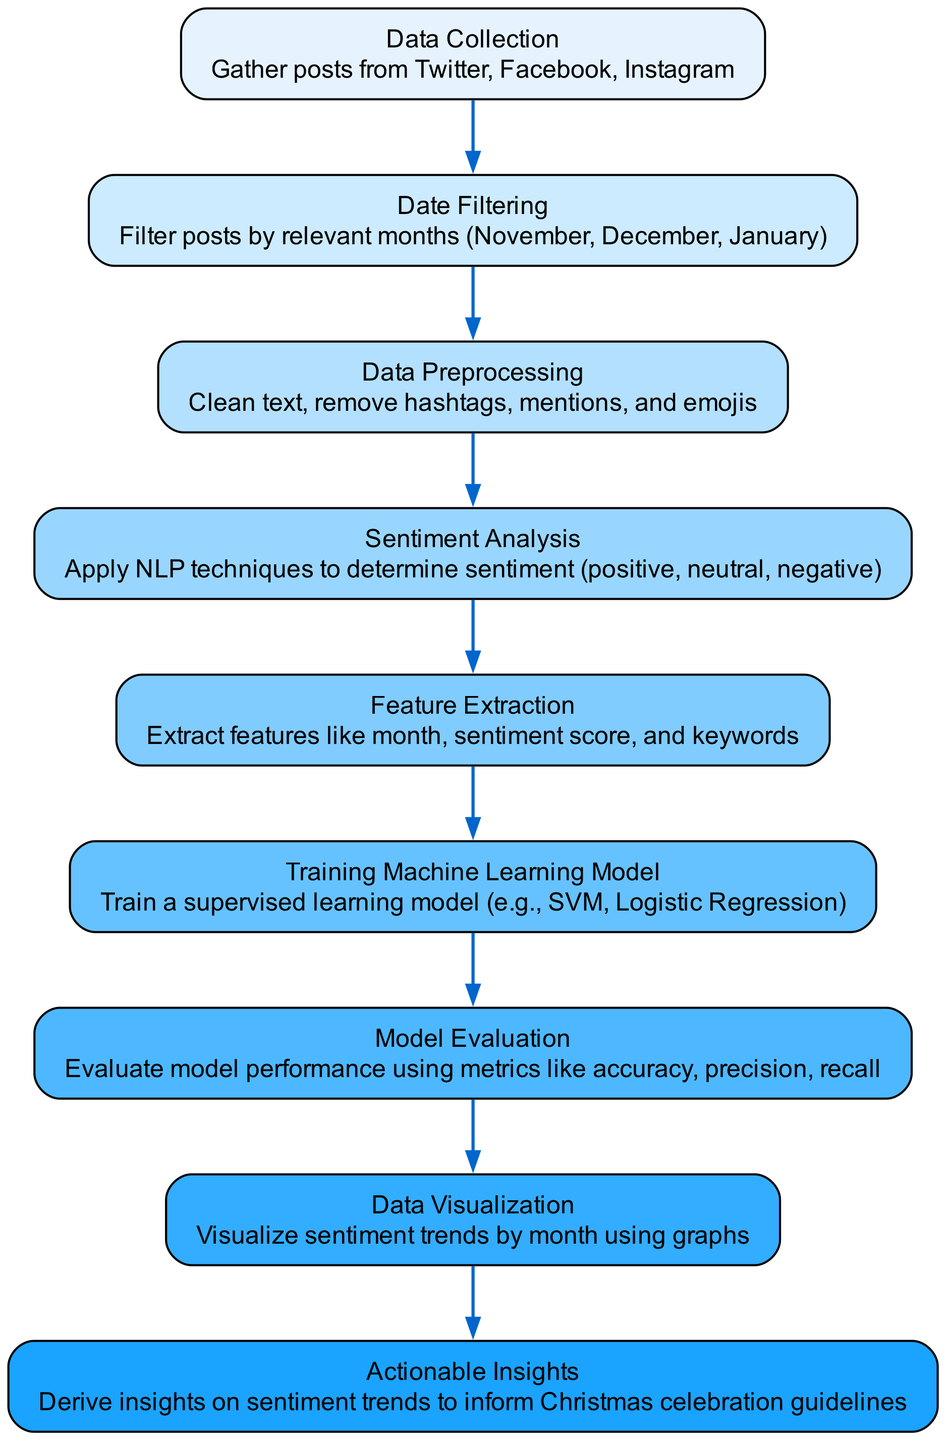What is the first node in the diagram? The first node is labeled "Data Collection". It is depicted as the starting point of the flow in the diagram.
Answer: Data Collection How many edges are there in total? By counting the connections shown in the diagram, there are eight connections (edges) between nodes.
Answer: 8 What node follows "Sentiment Analysis"? The node that follows "Sentiment Analysis" is "Feature Extraction". This connection shows the direct sequence of actions taking place in the analysis process.
Answer: Feature Extraction Which node is responsible for deriving insights? The node responsible for deriving insights is "Actionable Insights". It is the final step in the process and utilizes the findings from the previous stages.
Answer: Actionable Insights What method is used for training the model? The method used for training the model is "SVM, Logistic Regression". This specifies the supervised learning techniques being applied as part of the training process.
Answer: SVM, Logistic Regression What is filtered in the "Date Filtering" node? Posts are filtered by relevant months (November, December, January) in the "Date Filtering" node, which focuses the analysis on the specified timeframe.
Answer: November, December, January How does "Model Evaluation" connect to the diagram? "Model Evaluation" connects to the previous step "Training Machine Learning Model" and shows the flow of the process, indicating that model training is followed by evaluating its performance.
Answer: Connects from Training Machine Learning Model What sentiment categories are determined in "Sentiment Analysis"? The sentiment categories determined are positive, neutral, negative. This categorization is the core outcome of the sentiment analysis process.
Answer: Positive, Neutral, Negative What is visualized in the "Data Visualization" node? In the "Data Visualization" node, sentiment trends by month are visualized using graphs. This indicates that a graphical representation of the sentiments is created from the earlier data.
Answer: Sentiment trends by month 